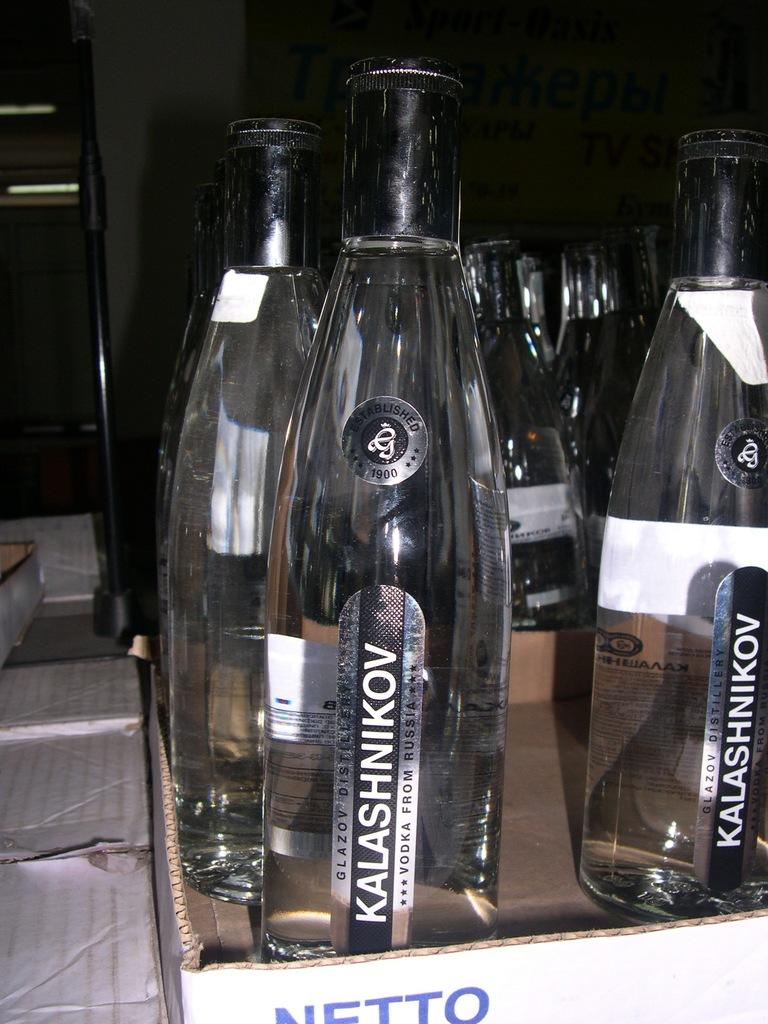What objects are present in the image? There are bottles in the image. How many tomatoes can be seen growing on the bottles in the image? There are no tomatoes present in the image, as it only features bottles. What emotion can be observed on the faces of the bottles in the image? Bottles do not have faces or the ability to express emotions like anger. What type of food is visible in the image, besides the bottles? There is no other type of food visible in the image besides the bottles. 